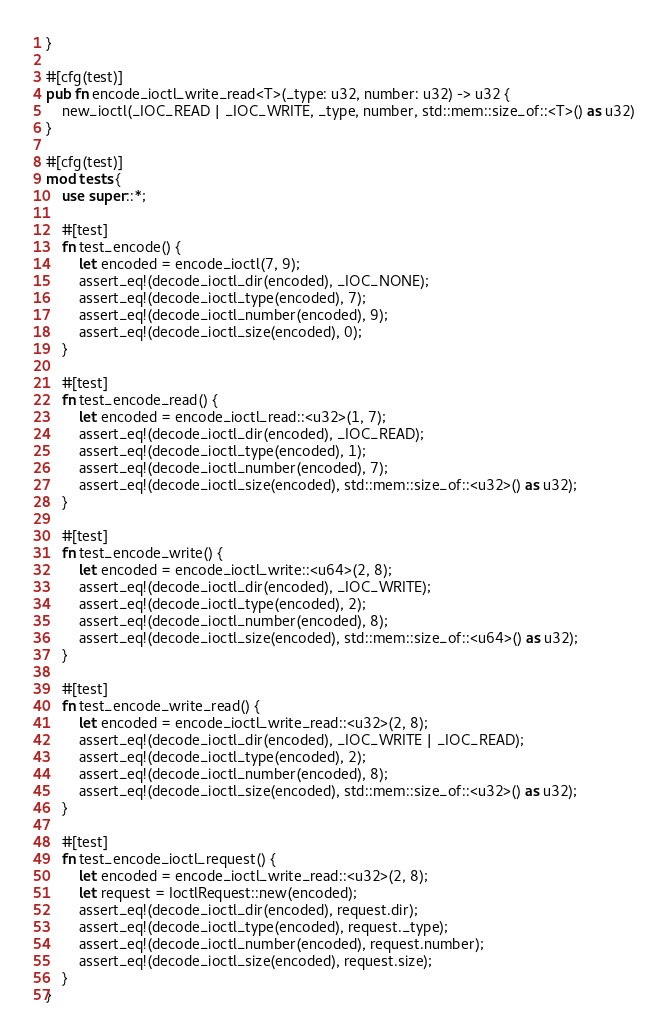Convert code to text. <code><loc_0><loc_0><loc_500><loc_500><_Rust_>}

#[cfg(test)]
pub fn encode_ioctl_write_read<T>(_type: u32, number: u32) -> u32 {
    new_ioctl(_IOC_READ | _IOC_WRITE, _type, number, std::mem::size_of::<T>() as u32)
}

#[cfg(test)]
mod tests {
    use super::*;

    #[test]
    fn test_encode() {
        let encoded = encode_ioctl(7, 9);
        assert_eq!(decode_ioctl_dir(encoded), _IOC_NONE);
        assert_eq!(decode_ioctl_type(encoded), 7);
        assert_eq!(decode_ioctl_number(encoded), 9);
        assert_eq!(decode_ioctl_size(encoded), 0);
    }

    #[test]
    fn test_encode_read() {
        let encoded = encode_ioctl_read::<u32>(1, 7);
        assert_eq!(decode_ioctl_dir(encoded), _IOC_READ);
        assert_eq!(decode_ioctl_type(encoded), 1);
        assert_eq!(decode_ioctl_number(encoded), 7);
        assert_eq!(decode_ioctl_size(encoded), std::mem::size_of::<u32>() as u32);
    }

    #[test]
    fn test_encode_write() {
        let encoded = encode_ioctl_write::<u64>(2, 8);
        assert_eq!(decode_ioctl_dir(encoded), _IOC_WRITE);
        assert_eq!(decode_ioctl_type(encoded), 2);
        assert_eq!(decode_ioctl_number(encoded), 8);
        assert_eq!(decode_ioctl_size(encoded), std::mem::size_of::<u64>() as u32);
    }

    #[test]
    fn test_encode_write_read() {
        let encoded = encode_ioctl_write_read::<u32>(2, 8);
        assert_eq!(decode_ioctl_dir(encoded), _IOC_WRITE | _IOC_READ);
        assert_eq!(decode_ioctl_type(encoded), 2);
        assert_eq!(decode_ioctl_number(encoded), 8);
        assert_eq!(decode_ioctl_size(encoded), std::mem::size_of::<u32>() as u32);
    }

    #[test]
    fn test_encode_ioctl_request() {
        let encoded = encode_ioctl_write_read::<u32>(2, 8);
        let request = IoctlRequest::new(encoded);
        assert_eq!(decode_ioctl_dir(encoded), request.dir);
        assert_eq!(decode_ioctl_type(encoded), request._type);
        assert_eq!(decode_ioctl_number(encoded), request.number);
        assert_eq!(decode_ioctl_size(encoded), request.size);
    }
}
</code> 